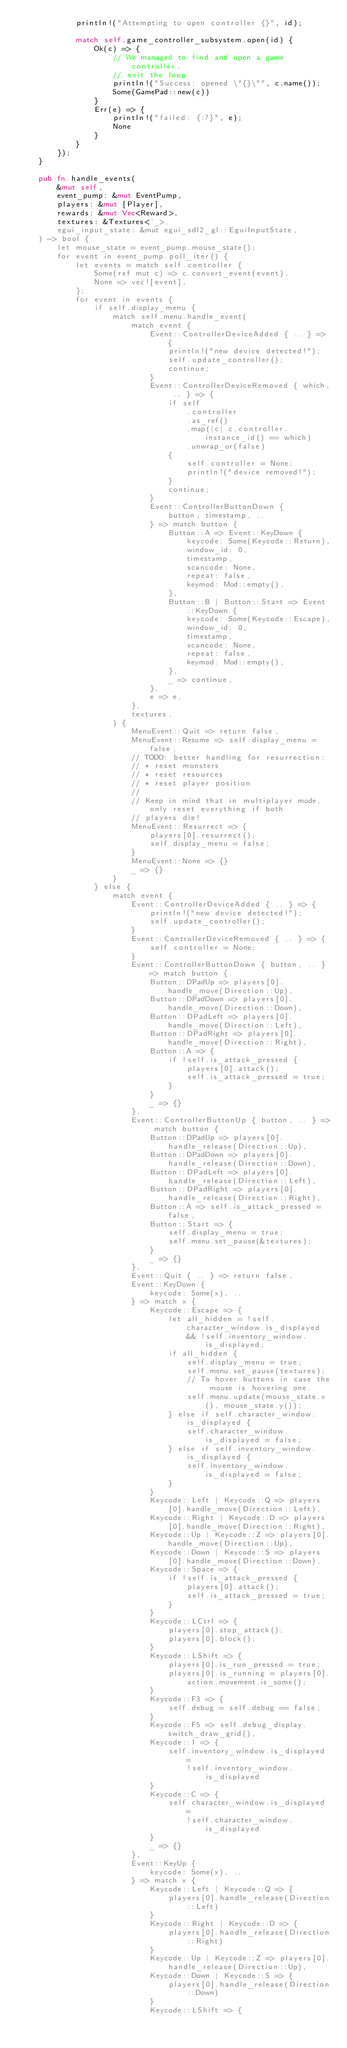Convert code to text. <code><loc_0><loc_0><loc_500><loc_500><_Rust_>            println!("Attempting to open controller {}", id);

            match self.game_controller_subsystem.open(id) {
                Ok(c) => {
                    // We managed to find and open a game controller,
                    // exit the loop
                    println!("Success: opened \"{}\"", c.name());
                    Some(GamePad::new(c))
                }
                Err(e) => {
                    println!("failed: {:?}", e);
                    None
                }
            }
        });
    }

    pub fn handle_events(
        &mut self,
        event_pump: &mut EventPump,
        players: &mut [Player],
        rewards: &mut Vec<Reward>,
        textures: &Textures<'_>,
        egui_input_state: &mut egui_sdl2_gl::EguiInputState,
    ) -> bool {
        let mouse_state = event_pump.mouse_state();
        for event in event_pump.poll_iter() {
            let events = match self.controller {
                Some(ref mut c) => c.convert_event(event),
                None => vec![event],
            };
            for event in events {
                if self.display_menu {
                    match self.menu.handle_event(
                        match event {
                            Event::ControllerDeviceAdded { .. } => {
                                println!("new device detected!");
                                self.update_controller();
                                continue;
                            }
                            Event::ControllerDeviceRemoved { which, .. } => {
                                if self
                                    .controller
                                    .as_ref()
                                    .map(|c| c.controller.instance_id() == which)
                                    .unwrap_or(false)
                                {
                                    self.controller = None;
                                    println!("device removed!");
                                }
                                continue;
                            }
                            Event::ControllerButtonDown {
                                button, timestamp, ..
                            } => match button {
                                Button::A => Event::KeyDown {
                                    keycode: Some(Keycode::Return),
                                    window_id: 0,
                                    timestamp,
                                    scancode: None,
                                    repeat: false,
                                    keymod: Mod::empty(),
                                },
                                Button::B | Button::Start => Event::KeyDown {
                                    keycode: Some(Keycode::Escape),
                                    window_id: 0,
                                    timestamp,
                                    scancode: None,
                                    repeat: false,
                                    keymod: Mod::empty(),
                                },
                                _ => continue,
                            },
                            e => e,
                        },
                        textures,
                    ) {
                        MenuEvent::Quit => return false,
                        MenuEvent::Resume => self.display_menu = false,
                        // TODO: better handling for resurrection:
                        // * reset monsters
                        // * reset resources
                        // * reset player position
                        //
                        // Keep in mind that in multiplayer mode, only reset everything if both
                        // players die!
                        MenuEvent::Resurrect => {
                            players[0].resurrect();
                            self.display_menu = false;
                        }
                        MenuEvent::None => {}
                        _ => {}
                    }
                } else {
                    match event {
                        Event::ControllerDeviceAdded { .. } => {
                            println!("new device detected!");
                            self.update_controller();
                        }
                        Event::ControllerDeviceRemoved { .. } => {
                            self.controller = None;
                        }
                        Event::ControllerButtonDown { button, .. } => match button {
                            Button::DPadUp => players[0].handle_move(Direction::Up),
                            Button::DPadDown => players[0].handle_move(Direction::Down),
                            Button::DPadLeft => players[0].handle_move(Direction::Left),
                            Button::DPadRight => players[0].handle_move(Direction::Right),
                            Button::A => {
                                if !self.is_attack_pressed {
                                    players[0].attack();
                                    self.is_attack_pressed = true;
                                }
                            }
                            _ => {}
                        },
                        Event::ControllerButtonUp { button, .. } => match button {
                            Button::DPadUp => players[0].handle_release(Direction::Up),
                            Button::DPadDown => players[0].handle_release(Direction::Down),
                            Button::DPadLeft => players[0].handle_release(Direction::Left),
                            Button::DPadRight => players[0].handle_release(Direction::Right),
                            Button::A => self.is_attack_pressed = false,
                            Button::Start => {
                                self.display_menu = true;
                                self.menu.set_pause(&textures);
                            }
                            _ => {}
                        },
                        Event::Quit { .. } => return false,
                        Event::KeyDown {
                            keycode: Some(x), ..
                        } => match x {
                            Keycode::Escape => {
                                let all_hidden = !self.character_window.is_displayed
                                    && !self.inventory_window.is_displayed;
                                if all_hidden {
                                    self.display_menu = true;
                                    self.menu.set_pause(textures);
                                    // To hover buttons in case the mouse is hovering one.
                                    self.menu.update(mouse_state.x(), mouse_state.y());
                                } else if self.character_window.is_displayed {
                                    self.character_window.is_displayed = false;
                                } else if self.inventory_window.is_displayed {
                                    self.inventory_window.is_displayed = false;
                                }
                            }
                            Keycode::Left | Keycode::Q => players[0].handle_move(Direction::Left),
                            Keycode::Right | Keycode::D => players[0].handle_move(Direction::Right),
                            Keycode::Up | Keycode::Z => players[0].handle_move(Direction::Up),
                            Keycode::Down | Keycode::S => players[0].handle_move(Direction::Down),
                            Keycode::Space => {
                                if !self.is_attack_pressed {
                                    players[0].attack();
                                    self.is_attack_pressed = true;
                                }
                            }
                            Keycode::LCtrl => {
                                players[0].stop_attack();
                                players[0].block();
                            }
                            Keycode::LShift => {
                                players[0].is_run_pressed = true;
                                players[0].is_running = players[0].action.movement.is_some();
                            }
                            Keycode::F3 => {
                                self.debug = self.debug == false;
                            }
                            Keycode::F5 => self.debug_display.switch_draw_grid(),
                            Keycode::I => {
                                self.inventory_window.is_displayed =
                                    !self.inventory_window.is_displayed
                            }
                            Keycode::C => {
                                self.character_window.is_displayed =
                                    !self.character_window.is_displayed
                            }
                            _ => {}
                        },
                        Event::KeyUp {
                            keycode: Some(x), ..
                        } => match x {
                            Keycode::Left | Keycode::Q => {
                                players[0].handle_release(Direction::Left)
                            }
                            Keycode::Right | Keycode::D => {
                                players[0].handle_release(Direction::Right)
                            }
                            Keycode::Up | Keycode::Z => players[0].handle_release(Direction::Up),
                            Keycode::Down | Keycode::S => {
                                players[0].handle_release(Direction::Down)
                            }
                            Keycode::LShift => {</code> 